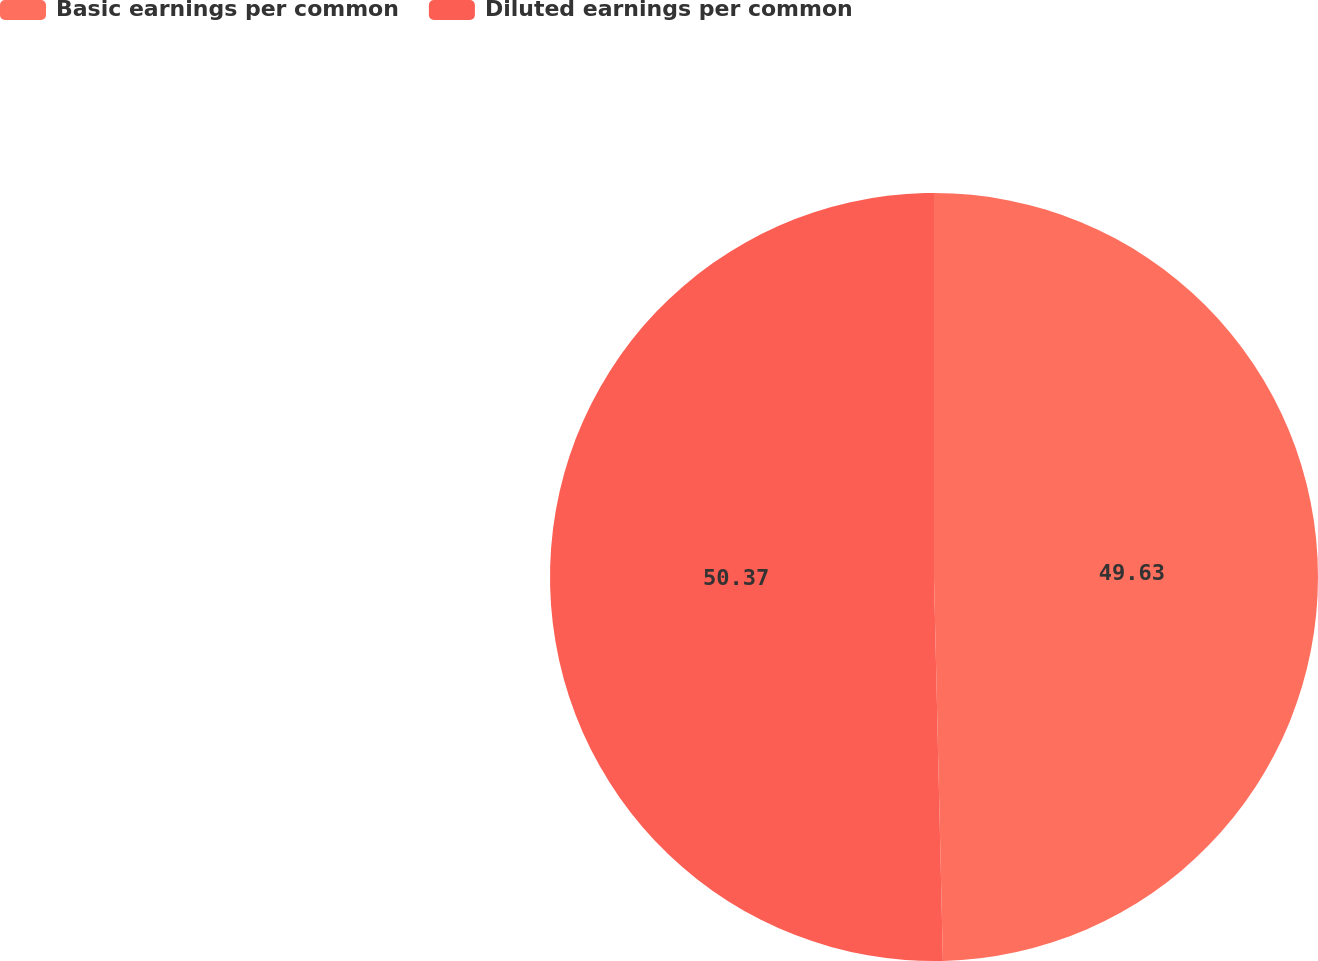Convert chart. <chart><loc_0><loc_0><loc_500><loc_500><pie_chart><fcel>Basic earnings per common<fcel>Diluted earnings per common<nl><fcel>49.63%<fcel>50.37%<nl></chart> 